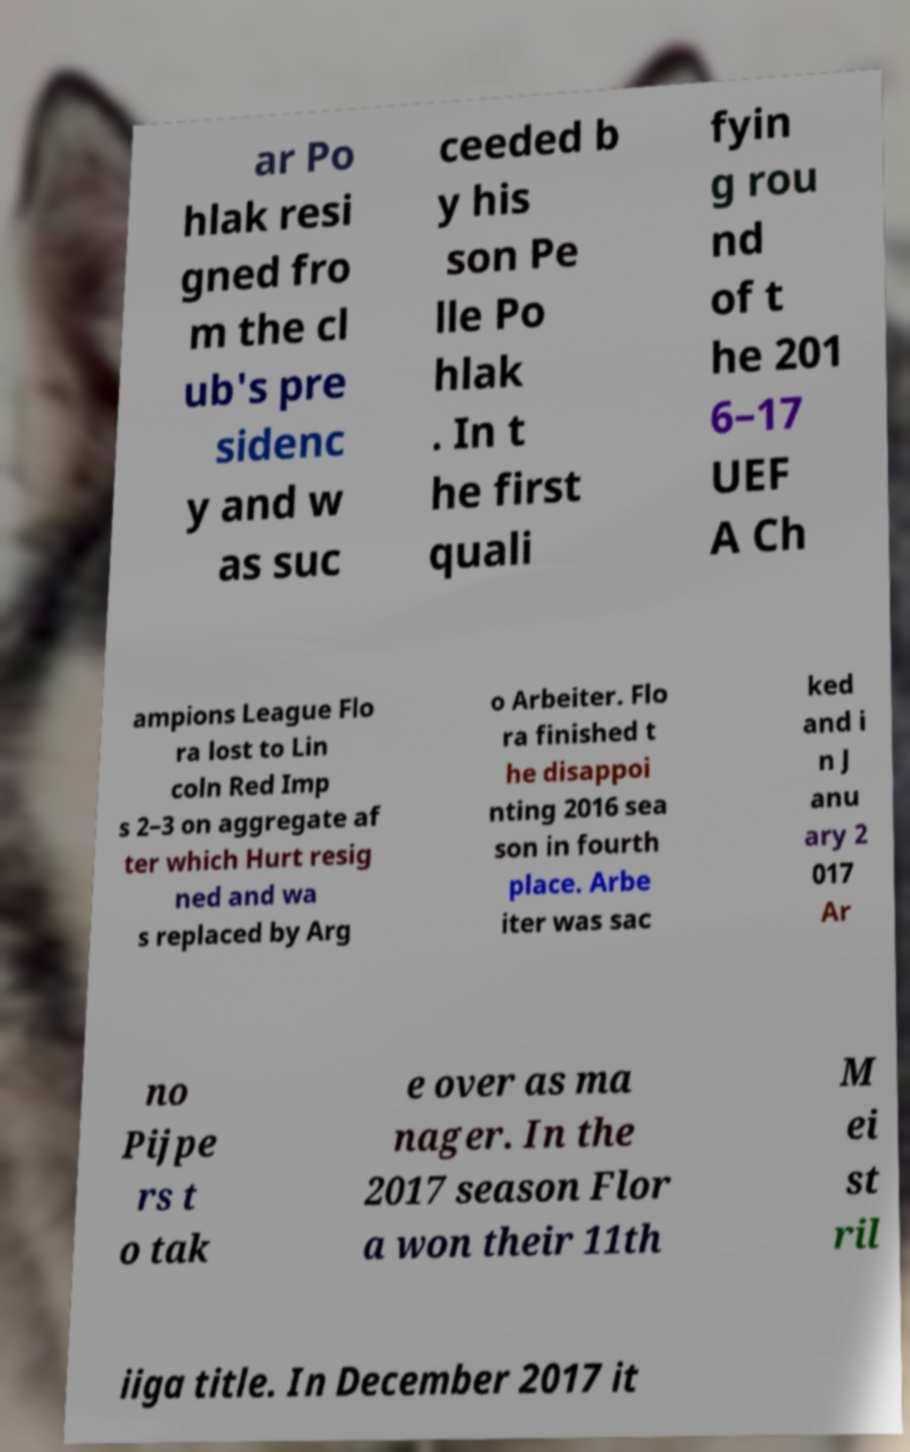What messages or text are displayed in this image? I need them in a readable, typed format. ar Po hlak resi gned fro m the cl ub's pre sidenc y and w as suc ceeded b y his son Pe lle Po hlak . In t he first quali fyin g rou nd of t he 201 6–17 UEF A Ch ampions League Flo ra lost to Lin coln Red Imp s 2–3 on aggregate af ter which Hurt resig ned and wa s replaced by Arg o Arbeiter. Flo ra finished t he disappoi nting 2016 sea son in fourth place. Arbe iter was sac ked and i n J anu ary 2 017 Ar no Pijpe rs t o tak e over as ma nager. In the 2017 season Flor a won their 11th M ei st ril iiga title. In December 2017 it 